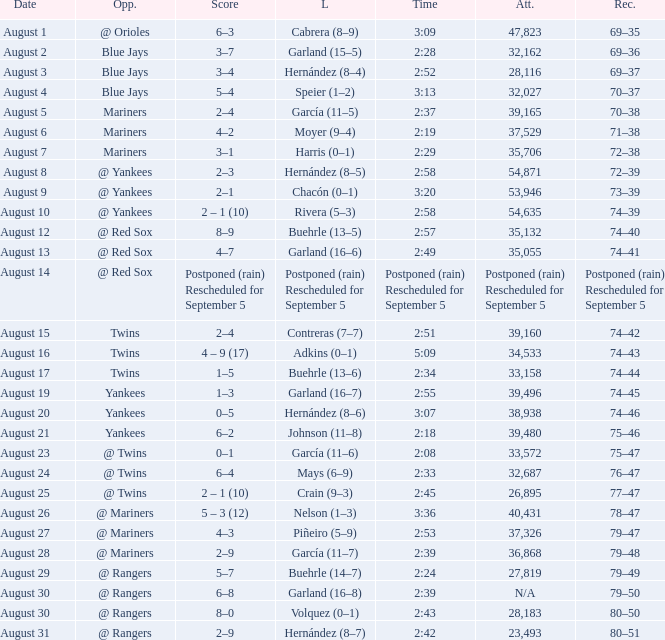Who suffered a loss on august 27? Piñeiro (5–9). Would you mind parsing the complete table? {'header': ['Date', 'Opp.', 'Score', 'L', 'Time', 'Att.', 'Rec.'], 'rows': [['August 1', '@ Orioles', '6–3', 'Cabrera (8–9)', '3:09', '47,823', '69–35'], ['August 2', 'Blue Jays', '3–7', 'Garland (15–5)', '2:28', '32,162', '69–36'], ['August 3', 'Blue Jays', '3–4', 'Hernández (8–4)', '2:52', '28,116', '69–37'], ['August 4', 'Blue Jays', '5–4', 'Speier (1–2)', '3:13', '32,027', '70–37'], ['August 5', 'Mariners', '2–4', 'García (11–5)', '2:37', '39,165', '70–38'], ['August 6', 'Mariners', '4–2', 'Moyer (9–4)', '2:19', '37,529', '71–38'], ['August 7', 'Mariners', '3–1', 'Harris (0–1)', '2:29', '35,706', '72–38'], ['August 8', '@ Yankees', '2–3', 'Hernández (8–5)', '2:58', '54,871', '72–39'], ['August 9', '@ Yankees', '2–1', 'Chacón (0–1)', '3:20', '53,946', '73–39'], ['August 10', '@ Yankees', '2 – 1 (10)', 'Rivera (5–3)', '2:58', '54,635', '74–39'], ['August 12', '@ Red Sox', '8–9', 'Buehrle (13–5)', '2:57', '35,132', '74–40'], ['August 13', '@ Red Sox', '4–7', 'Garland (16–6)', '2:49', '35,055', '74–41'], ['August 14', '@ Red Sox', 'Postponed (rain) Rescheduled for September 5', 'Postponed (rain) Rescheduled for September 5', 'Postponed (rain) Rescheduled for September 5', 'Postponed (rain) Rescheduled for September 5', 'Postponed (rain) Rescheduled for September 5'], ['August 15', 'Twins', '2–4', 'Contreras (7–7)', '2:51', '39,160', '74–42'], ['August 16', 'Twins', '4 – 9 (17)', 'Adkins (0–1)', '5:09', '34,533', '74–43'], ['August 17', 'Twins', '1–5', 'Buehrle (13–6)', '2:34', '33,158', '74–44'], ['August 19', 'Yankees', '1–3', 'Garland (16–7)', '2:55', '39,496', '74–45'], ['August 20', 'Yankees', '0–5', 'Hernández (8–6)', '3:07', '38,938', '74–46'], ['August 21', 'Yankees', '6–2', 'Johnson (11–8)', '2:18', '39,480', '75–46'], ['August 23', '@ Twins', '0–1', 'García (11–6)', '2:08', '33,572', '75–47'], ['August 24', '@ Twins', '6–4', 'Mays (6–9)', '2:33', '32,687', '76–47'], ['August 25', '@ Twins', '2 – 1 (10)', 'Crain (9–3)', '2:45', '26,895', '77–47'], ['August 26', '@ Mariners', '5 – 3 (12)', 'Nelson (1–3)', '3:36', '40,431', '78–47'], ['August 27', '@ Mariners', '4–3', 'Piñeiro (5–9)', '2:53', '37,326', '79–47'], ['August 28', '@ Mariners', '2–9', 'García (11–7)', '2:39', '36,868', '79–48'], ['August 29', '@ Rangers', '5–7', 'Buehrle (14–7)', '2:24', '27,819', '79–49'], ['August 30', '@ Rangers', '6–8', 'Garland (16–8)', '2:39', 'N/A', '79–50'], ['August 30', '@ Rangers', '8–0', 'Volquez (0–1)', '2:43', '28,183', '80–50'], ['August 31', '@ Rangers', '2–9', 'Hernández (8–7)', '2:42', '23,493', '80–51']]} 